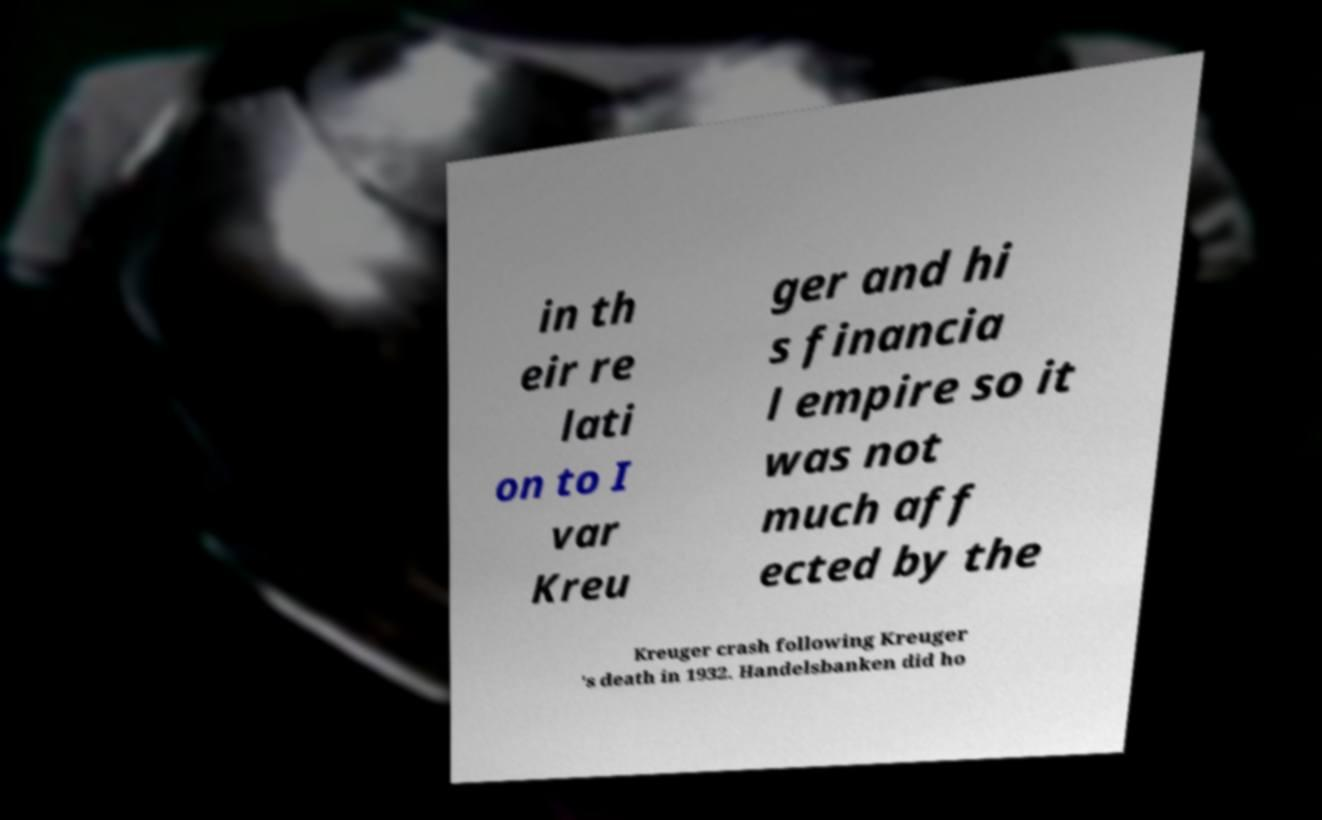Can you read and provide the text displayed in the image?This photo seems to have some interesting text. Can you extract and type it out for me? in th eir re lati on to I var Kreu ger and hi s financia l empire so it was not much aff ected by the Kreuger crash following Kreuger 's death in 1932. Handelsbanken did ho 